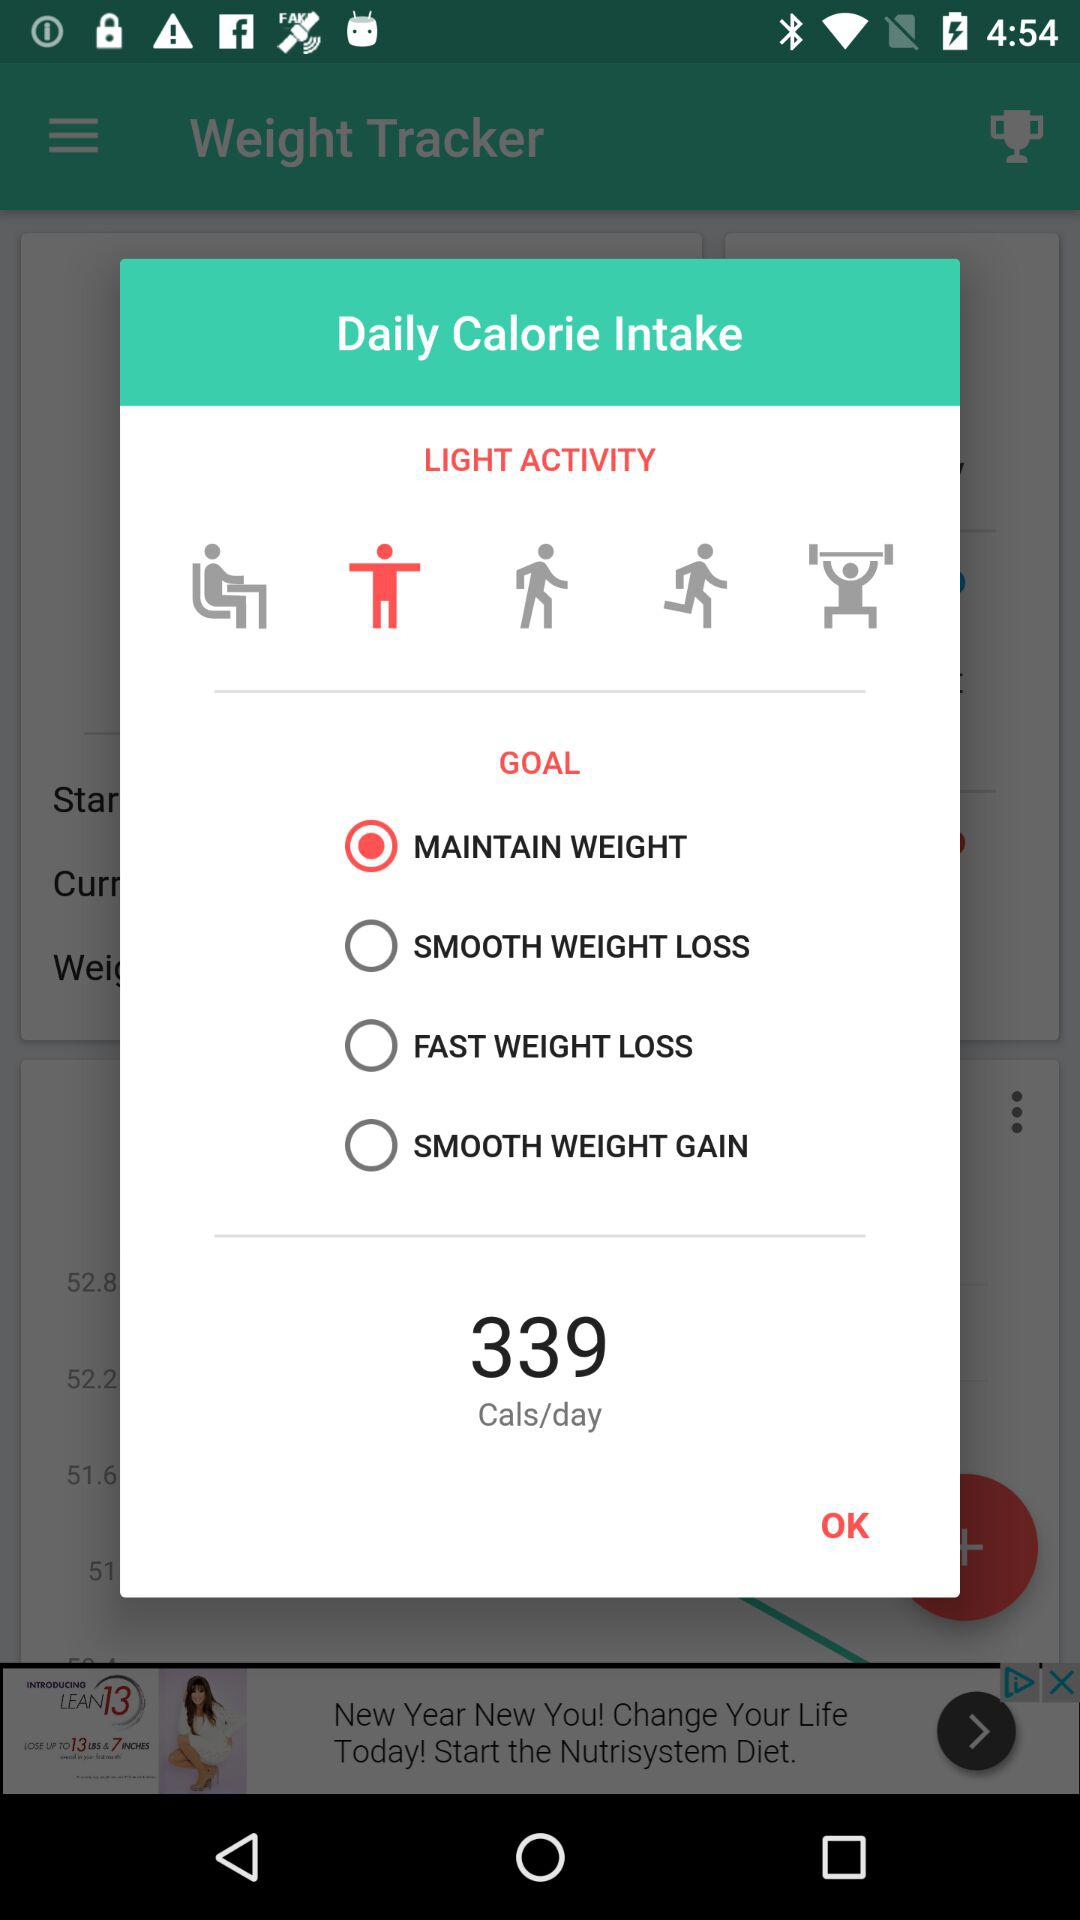How many calories are displayed? The number of displayed calories is 339. 